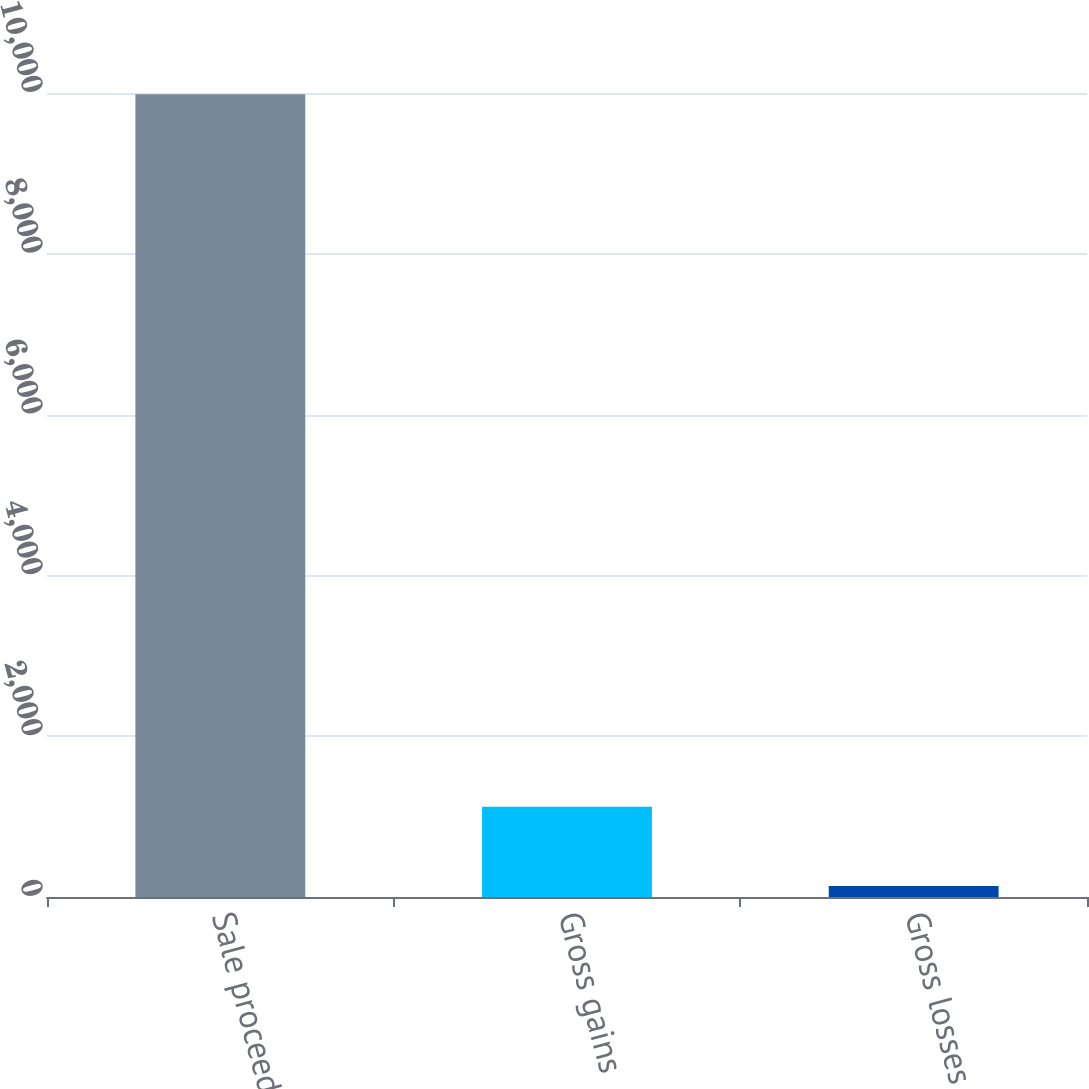Convert chart to OTSL. <chart><loc_0><loc_0><loc_500><loc_500><bar_chart><fcel>Sale proceeds<fcel>Gross gains<fcel>Gross losses<nl><fcel>9984<fcel>1122.6<fcel>138<nl></chart> 